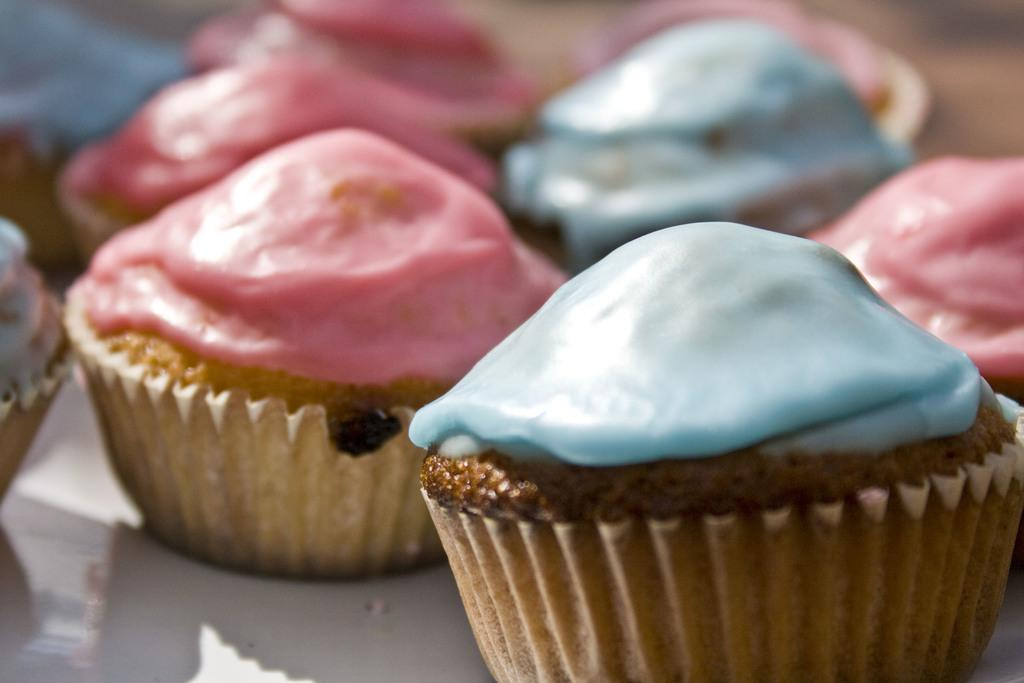What type of dessert is featured in the image? There are cupcakes in the image. Can you see a dog's finger bursting in the image? There is no dog or finger present in the image, and therefore no such event can be observed. 